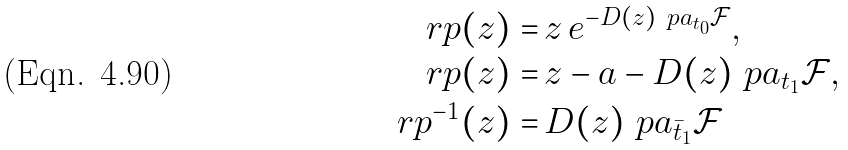Convert formula to latex. <formula><loc_0><loc_0><loc_500><loc_500>r p ( z ) = \, & z \, e ^ { - D ( z ) \ p a _ { t _ { 0 } } { \mathcal { F } } } , \\ r p ( z ) = \, & z - a - D ( z ) \ p a _ { t _ { 1 } } { \mathcal { F } } , \\ r p ^ { - 1 } ( z ) = \, & D ( z ) \ p a _ { \bar { t } _ { 1 } } { \mathcal { F } }</formula> 